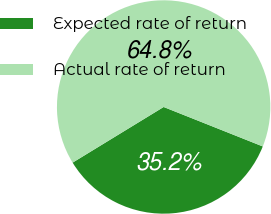Convert chart. <chart><loc_0><loc_0><loc_500><loc_500><pie_chart><fcel>Expected rate of return<fcel>Actual rate of return<nl><fcel>35.24%<fcel>64.76%<nl></chart> 